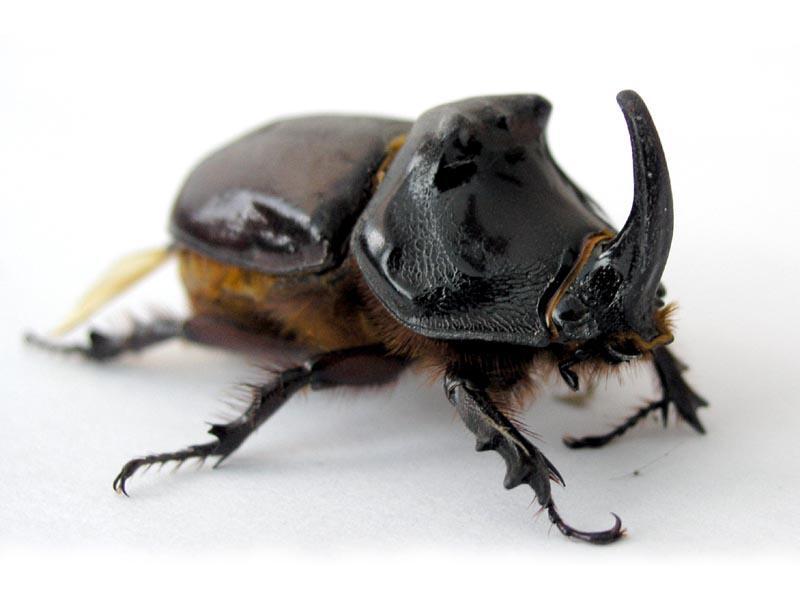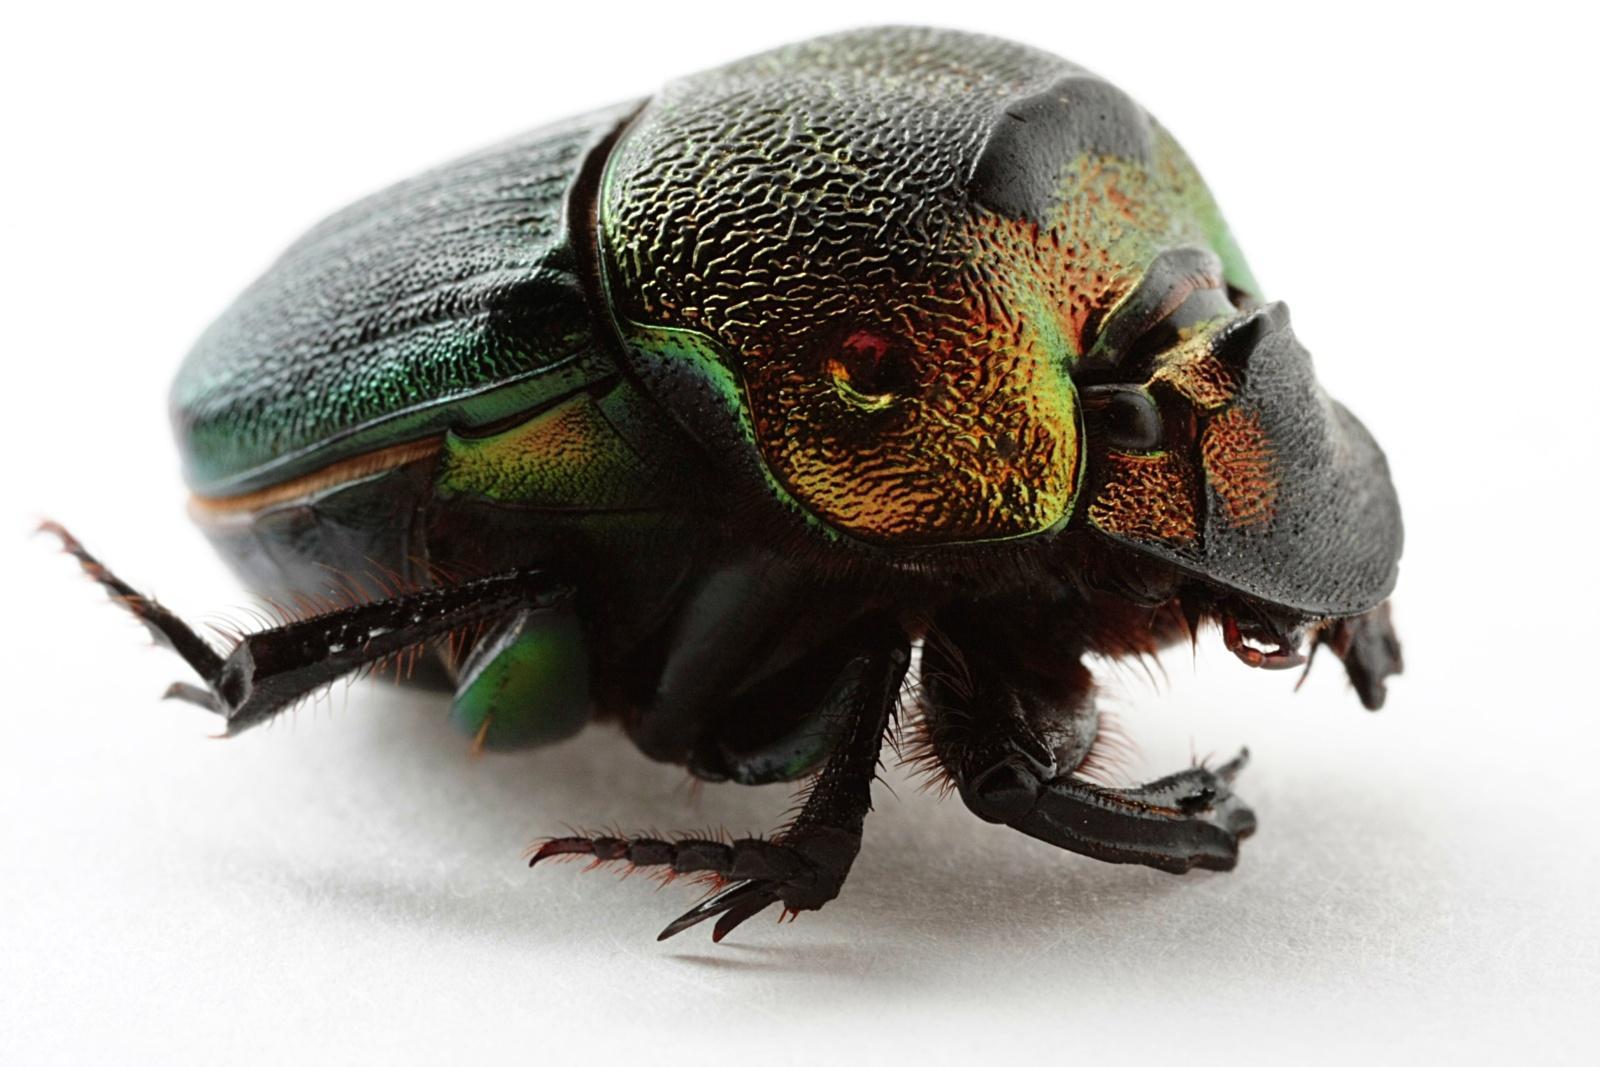The first image is the image on the left, the second image is the image on the right. For the images shown, is this caption "At least one beetle crawls on a clod of dirt in each of the images." true? Answer yes or no. No. The first image is the image on the left, the second image is the image on the right. For the images displayed, is the sentence "There are at least two beetles touching  a dungball." factually correct? Answer yes or no. No. 